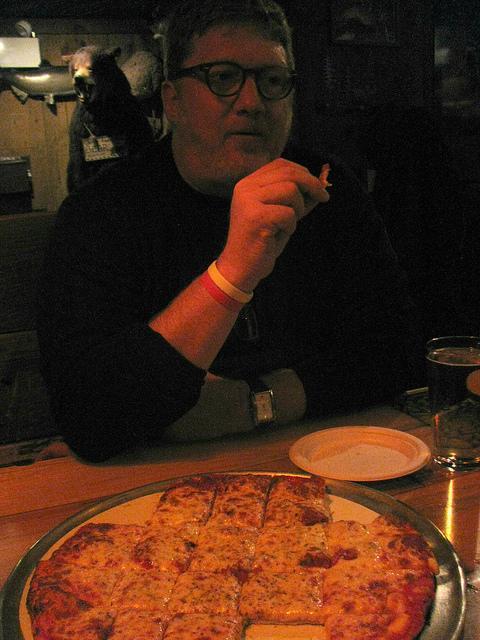How many elephants are there?
Give a very brief answer. 0. 